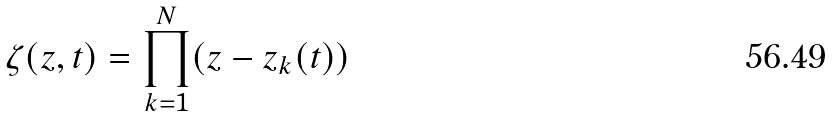Convert formula to latex. <formula><loc_0><loc_0><loc_500><loc_500>\zeta ( { z } , t ) = \prod _ { k = 1 } ^ { N } ( { z } - { z } _ { k } ( t ) )</formula> 